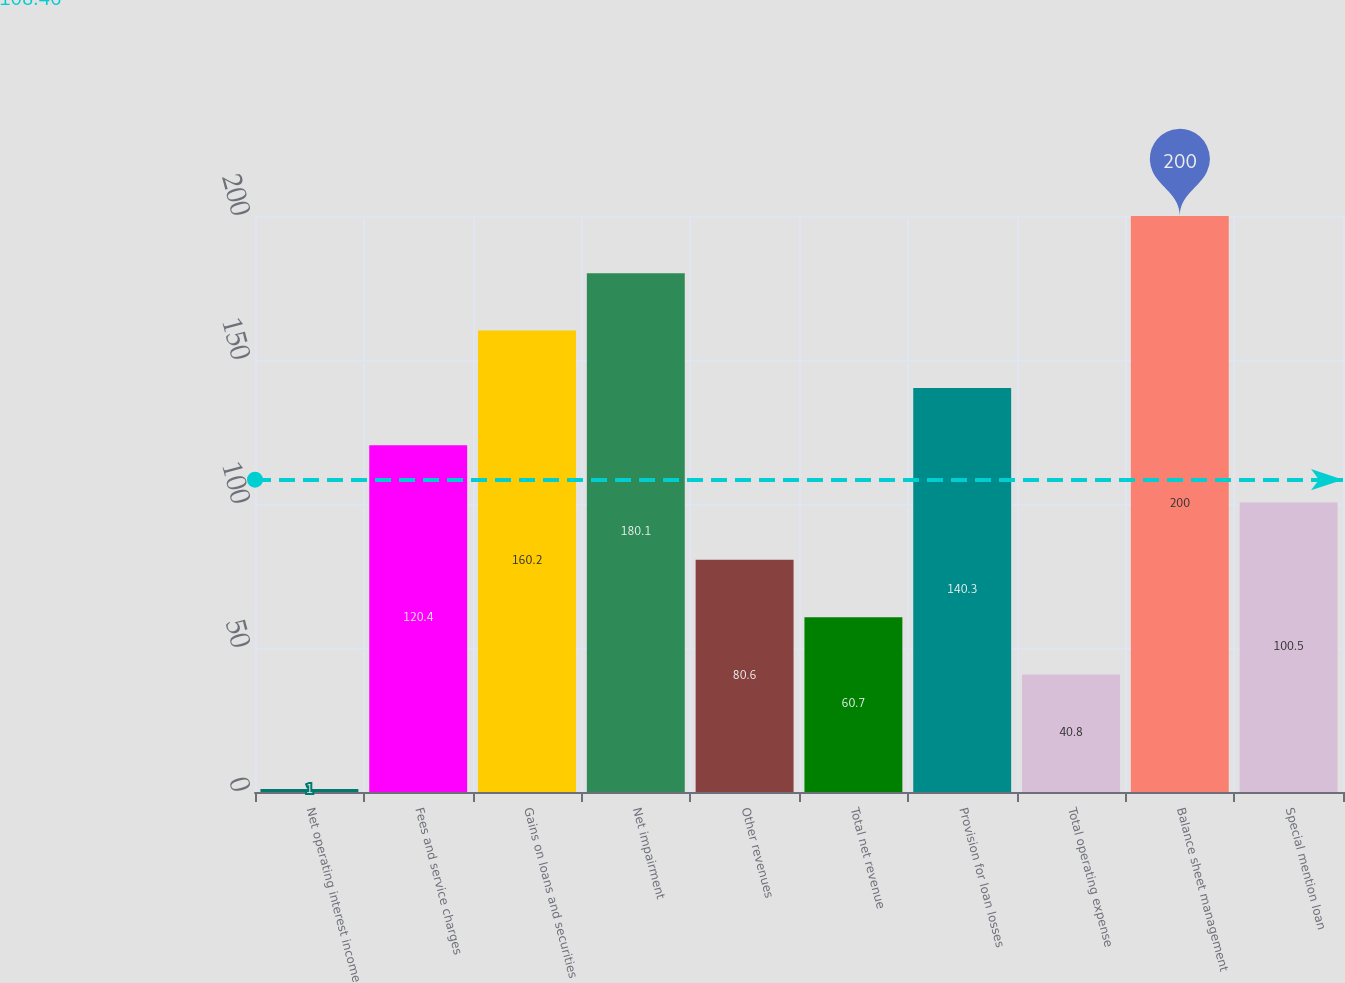Convert chart to OTSL. <chart><loc_0><loc_0><loc_500><loc_500><bar_chart><fcel>Net operating interest income<fcel>Fees and service charges<fcel>Gains on loans and securities<fcel>Net impairment<fcel>Other revenues<fcel>Total net revenue<fcel>Provision for loan losses<fcel>Total operating expense<fcel>Balance sheet management<fcel>Special mention loan<nl><fcel>1<fcel>120.4<fcel>160.2<fcel>180.1<fcel>80.6<fcel>60.7<fcel>140.3<fcel>40.8<fcel>200<fcel>100.5<nl></chart> 